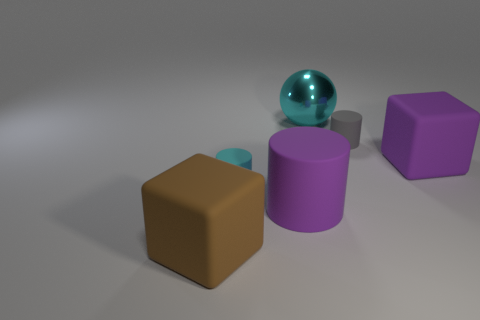Is there any other thing of the same color as the metal ball?
Make the answer very short. Yes. The matte thing that is the same color as the large metal thing is what shape?
Provide a succinct answer. Cylinder. There is a matte block on the right side of the large brown block; is it the same color as the big rubber cylinder?
Provide a succinct answer. Yes. How many things are big matte things that are right of the cyan matte cylinder or big rubber cylinders?
Make the answer very short. 2. Are there fewer matte objects that are in front of the purple matte cube than things on the right side of the tiny cyan matte thing?
Give a very brief answer. Yes. What number of other objects are there of the same size as the gray matte cylinder?
Your answer should be compact. 1. Is the large cylinder made of the same material as the big cube that is right of the large brown thing?
Your answer should be compact. Yes. How many objects are either objects behind the tiny cyan rubber thing or rubber things that are to the right of the brown thing?
Give a very brief answer. 5. The large cylinder is what color?
Your answer should be very brief. Purple. Is the number of brown rubber cubes behind the large metallic sphere less than the number of purple matte blocks?
Offer a very short reply. Yes. 